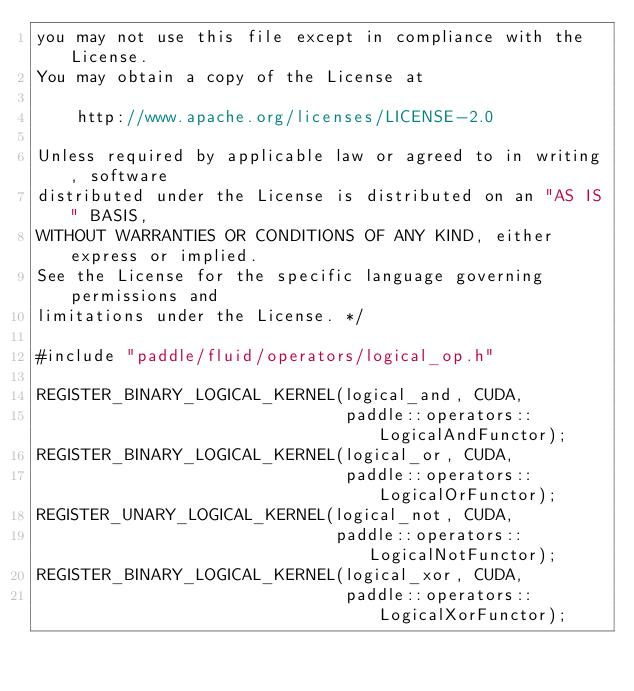Convert code to text. <code><loc_0><loc_0><loc_500><loc_500><_Cuda_>you may not use this file except in compliance with the License.
You may obtain a copy of the License at

    http://www.apache.org/licenses/LICENSE-2.0

Unless required by applicable law or agreed to in writing, software
distributed under the License is distributed on an "AS IS" BASIS,
WITHOUT WARRANTIES OR CONDITIONS OF ANY KIND, either express or implied.
See the License for the specific language governing permissions and
limitations under the License. */

#include "paddle/fluid/operators/logical_op.h"

REGISTER_BINARY_LOGICAL_KERNEL(logical_and, CUDA,
                               paddle::operators::LogicalAndFunctor);
REGISTER_BINARY_LOGICAL_KERNEL(logical_or, CUDA,
                               paddle::operators::LogicalOrFunctor);
REGISTER_UNARY_LOGICAL_KERNEL(logical_not, CUDA,
                              paddle::operators::LogicalNotFunctor);
REGISTER_BINARY_LOGICAL_KERNEL(logical_xor, CUDA,
                               paddle::operators::LogicalXorFunctor);
</code> 